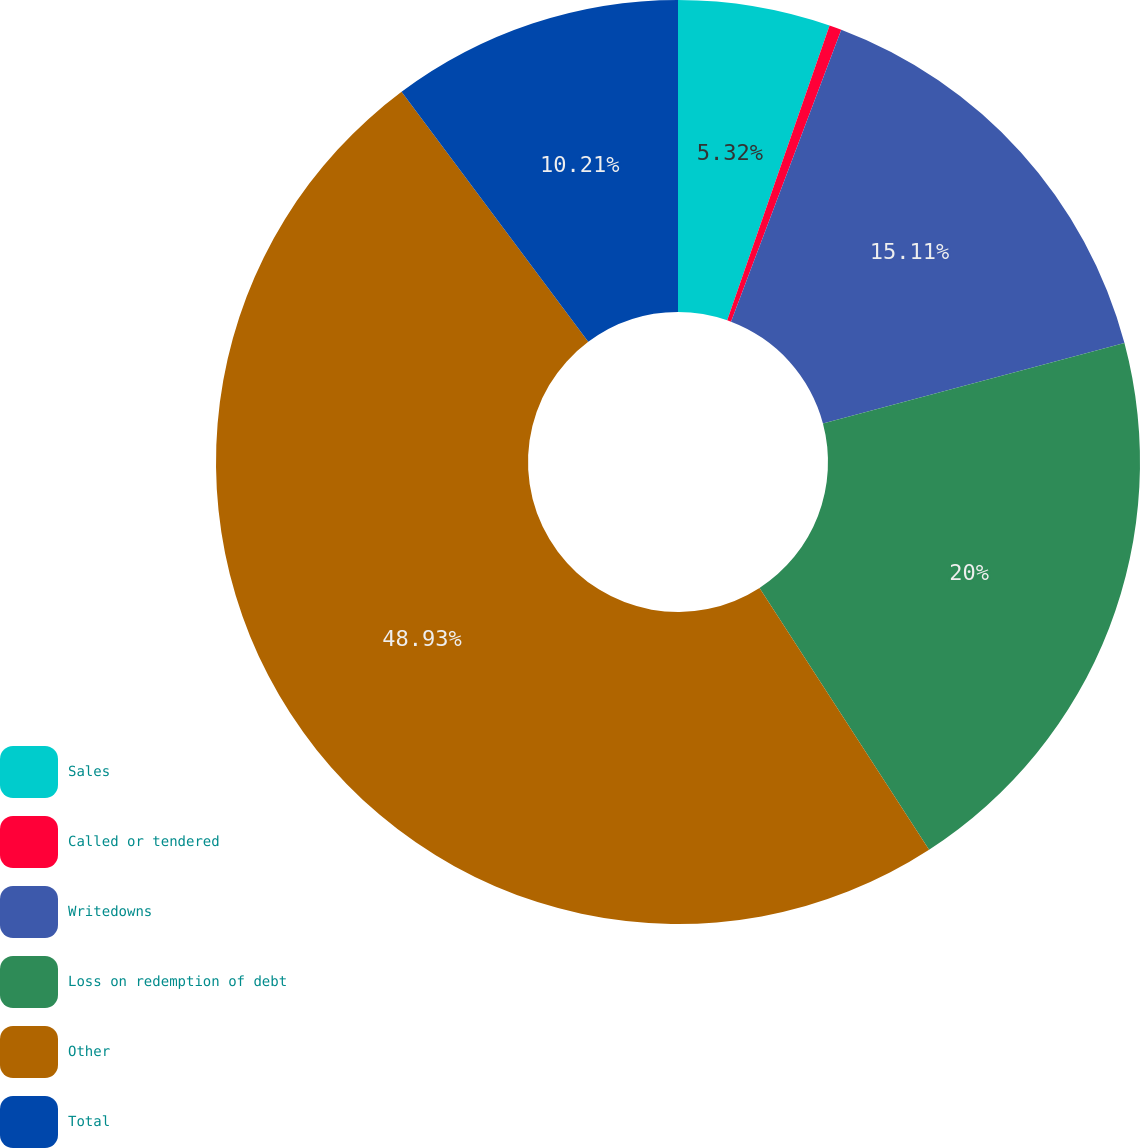<chart> <loc_0><loc_0><loc_500><loc_500><pie_chart><fcel>Sales<fcel>Called or tendered<fcel>Writedowns<fcel>Loss on redemption of debt<fcel>Other<fcel>Total<nl><fcel>5.32%<fcel>0.43%<fcel>15.11%<fcel>20.0%<fcel>48.94%<fcel>10.21%<nl></chart> 